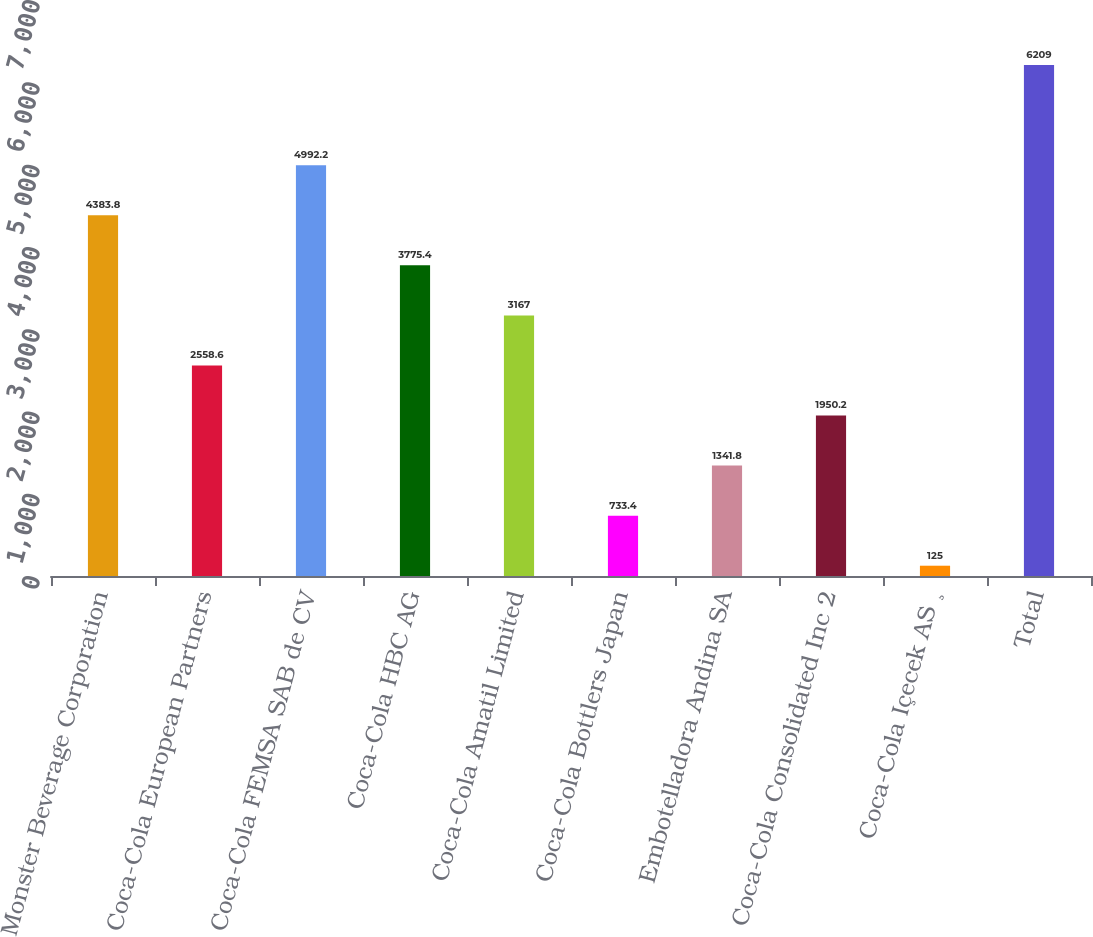Convert chart. <chart><loc_0><loc_0><loc_500><loc_500><bar_chart><fcel>Monster Beverage Corporation<fcel>Coca-Cola European Partners<fcel>Coca-Cola FEMSA SAB de CV<fcel>Coca-Cola HBC AG<fcel>Coca-Cola Amatil Limited<fcel>Coca-Cola Bottlers Japan<fcel>Embotelladora Andina SA<fcel>Coca-Cola Consolidated Inc 2<fcel>Coca-Cola Içecek AS ¸<fcel>Total<nl><fcel>4383.8<fcel>2558.6<fcel>4992.2<fcel>3775.4<fcel>3167<fcel>733.4<fcel>1341.8<fcel>1950.2<fcel>125<fcel>6209<nl></chart> 